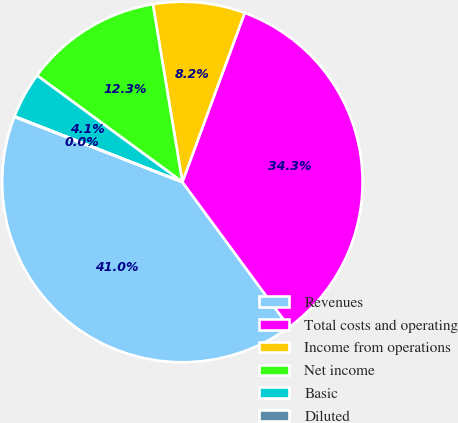Convert chart to OTSL. <chart><loc_0><loc_0><loc_500><loc_500><pie_chart><fcel>Revenues<fcel>Total costs and operating<fcel>Income from operations<fcel>Net income<fcel>Basic<fcel>Diluted<nl><fcel>40.99%<fcel>34.29%<fcel>8.23%<fcel>12.32%<fcel>4.13%<fcel>0.04%<nl></chart> 